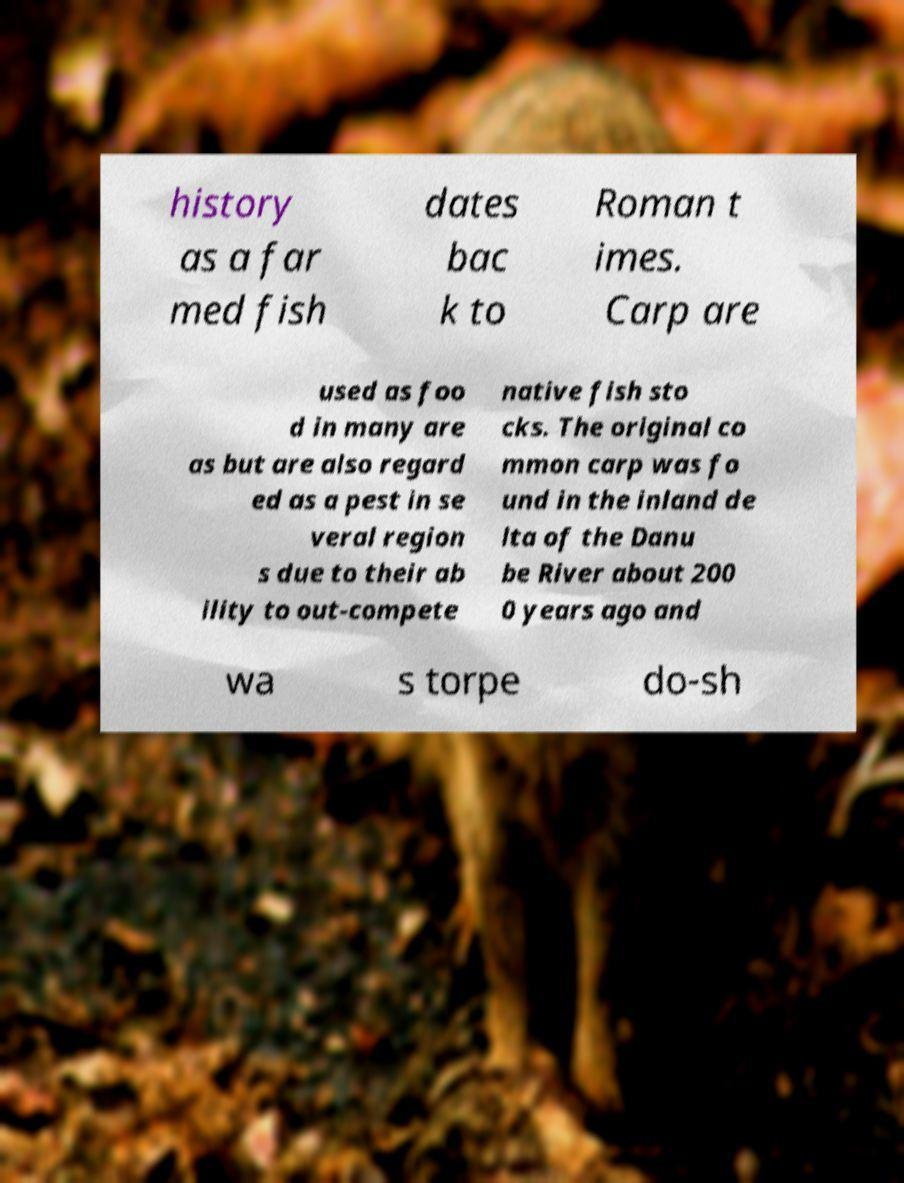Could you extract and type out the text from this image? history as a far med fish dates bac k to Roman t imes. Carp are used as foo d in many are as but are also regard ed as a pest in se veral region s due to their ab ility to out-compete native fish sto cks. The original co mmon carp was fo und in the inland de lta of the Danu be River about 200 0 years ago and wa s torpe do-sh 